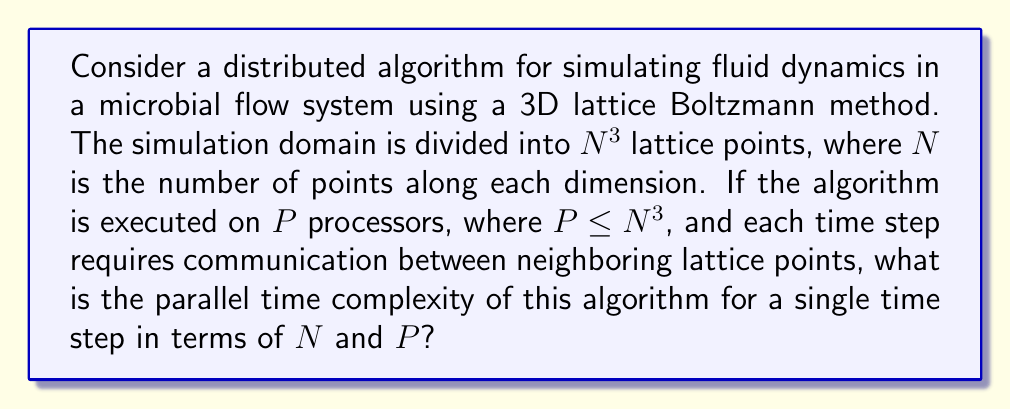Teach me how to tackle this problem. To analyze the parallel time complexity of this distributed algorithm, we need to consider both the computation and communication costs:

1. Computation:
   - The total number of lattice points is $N^3$.
   - With $P$ processors, each processor handles approximately $\frac{N^3}{P}$ lattice points.
   - The computation time for each lattice point is constant, let's call it $c$.
   - So, the computation time per processor is $O(\frac{N^3}{P} \cdot c) = O(\frac{N^3}{P})$.

2. Communication:
   - Each lattice point needs to communicate with its neighbors (typically 26 neighbors in a 3D lattice).
   - The communication time depends on the network topology and the number of processors.
   - In the worst case, when $P = N^3$, each processor handles one lattice point and needs to communicate with up to 26 other processors.
   - The communication time can be approximated as $O(\log P)$ for typical interconnection networks.

3. Load balancing:
   - We assume perfect load balancing among processors.

4. Synchronization:
   - After each time step, processors need to synchronize, which takes $O(\log P)$ time.

The total parallel time for one time step is the sum of computation and communication times:

$$ T_{parallel} = O(\frac{N^3}{P}) + O(\log P) $$

This expression represents the trade-off between computation and communication. As we increase the number of processors, the computation time decreases, but the communication overhead increases.

The optimal number of processors is achieved when these two terms are balanced:

$$ \frac{N^3}{P} \approx \log P $$

However, for the given constraint $P \leq N^3$, the computation term will dominate in most practical cases.
Answer: The parallel time complexity for a single time step of the distributed fluid dynamics simulation algorithm is $O(\frac{N^3}{P} + \log P)$, where $N$ is the number of lattice points along each dimension and $P$ is the number of processors, with $P \leq N^3$. 